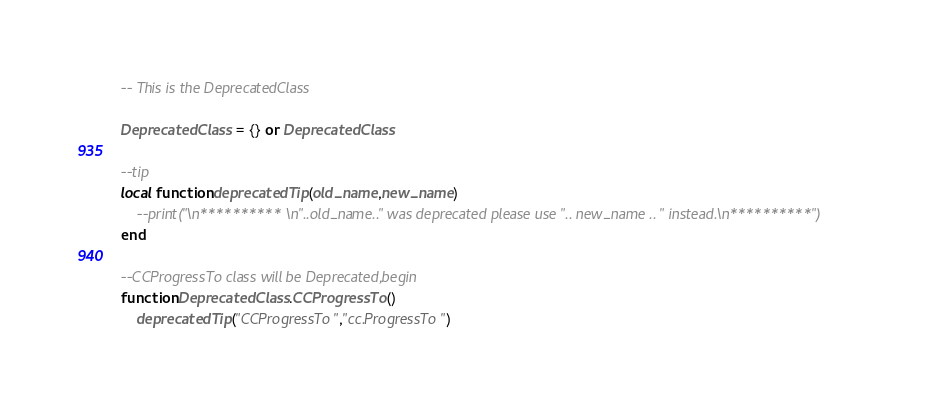<code> <loc_0><loc_0><loc_500><loc_500><_Lua_>-- This is the DeprecatedClass

DeprecatedClass = {} or DeprecatedClass

--tip
local function deprecatedTip(old_name,new_name)
    --print("\n********** \n"..old_name.." was deprecated please use ".. new_name .. " instead.\n**********")
end

--CCProgressTo class will be Deprecated,begin
function DeprecatedClass.CCProgressTo()
    deprecatedTip("CCProgressTo","cc.ProgressTo")</code> 